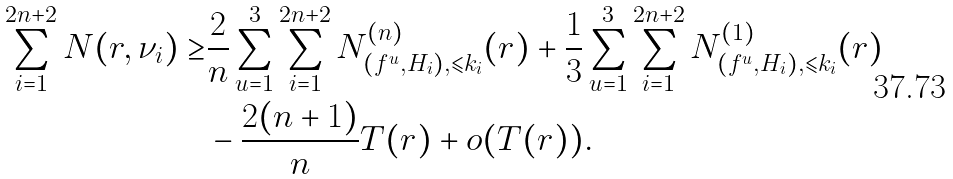Convert formula to latex. <formula><loc_0><loc_0><loc_500><loc_500>\sum _ { i = 1 } ^ { 2 n + 2 } N ( r , \nu _ { i } ) \geq & \frac { 2 } { n } \sum _ { u = 1 } ^ { 3 } \sum _ { i = 1 } ^ { 2 n + 2 } N ^ { ( n ) } _ { ( f ^ { u } , H _ { i } ) , \leqslant k _ { i } } ( r ) + \frac { 1 } { 3 } \sum _ { u = 1 } ^ { 3 } \sum _ { i = 1 } ^ { 2 n + 2 } N ^ { ( 1 ) } _ { ( f ^ { u } , H _ { i } ) , \leqslant k _ { i } } ( r ) \\ & - \frac { 2 ( n + 1 ) } { n } T ( r ) + o ( T ( r ) ) .</formula> 